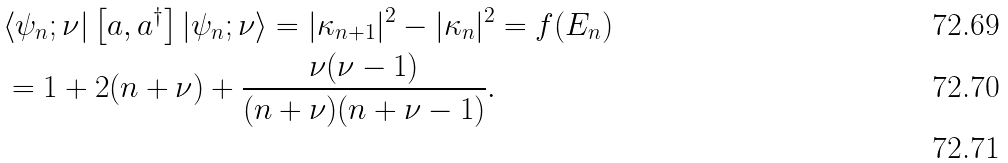Convert formula to latex. <formula><loc_0><loc_0><loc_500><loc_500>& \langle \psi _ { n } ; \nu | \left [ a , a ^ { \dagger } \right ] | \psi _ { n } ; \nu \rangle = | \kappa _ { n + 1 } | ^ { 2 } - | \kappa _ { n } | ^ { 2 } = f ( E _ { n } ) \\ & = 1 + 2 ( n + \nu ) + \frac { \nu ( \nu - 1 ) } { ( n + \nu ) ( n + \nu - 1 ) } . \\</formula> 